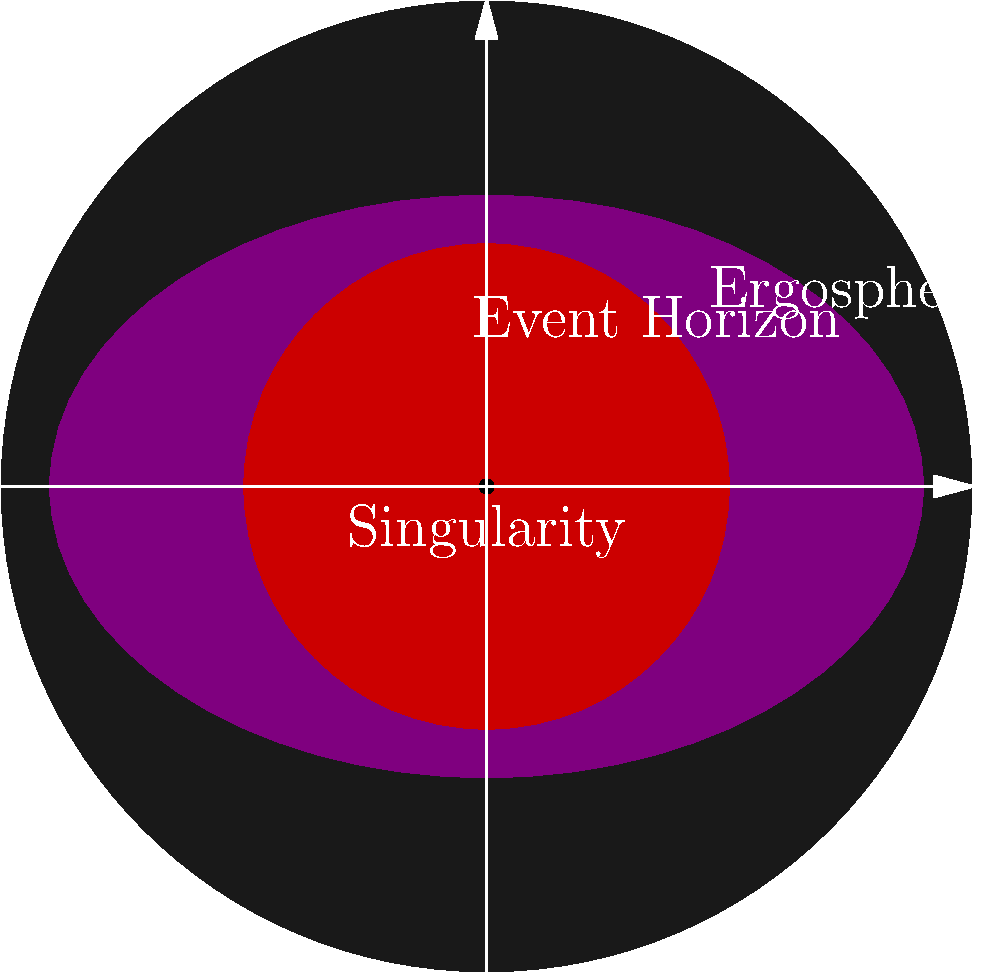In the cross-sectional view of a rotating black hole, what is the name of the region between the event horizon and the outer boundary where space-time starts to be dragged along with the black hole's rotation? To answer this question, let's break down the structure of a rotating black hole:

1. At the center, we have the singularity, where the laws of physics as we know them break down.

2. Surrounding the singularity is the event horizon, the boundary beyond which nothing can escape the black hole's gravitational pull. This is often referred to as the "point of no return."

3. For a rotating black hole (also known as a Kerr black hole), there's an additional region outside the event horizon called the ergosphere.

4. The ergosphere is a region where space-time is dragged along with the black hole's rotation, a phenomenon known as frame-dragging or the Lense-Thirring effect.

5. The outer boundary of the ergosphere is ellipsoidal in shape, touching the event horizon at the poles and bulging out at the equator.

6. Within the ergosphere, objects cannot remain stationary with respect to distant space. They are forced to rotate with the black hole, although they can still escape if they have sufficient velocity.

The region between the event horizon and the outer boundary of the ergosphere is what we're looking for in this question. This entire region is called the ergosphere.

The concept of the ergosphere might resonate with someone who has had a near-death experience, as it represents a space where the normal rules start to bend, much like how one might perceive time and space differently in extreme situations.
Answer: Ergosphere 